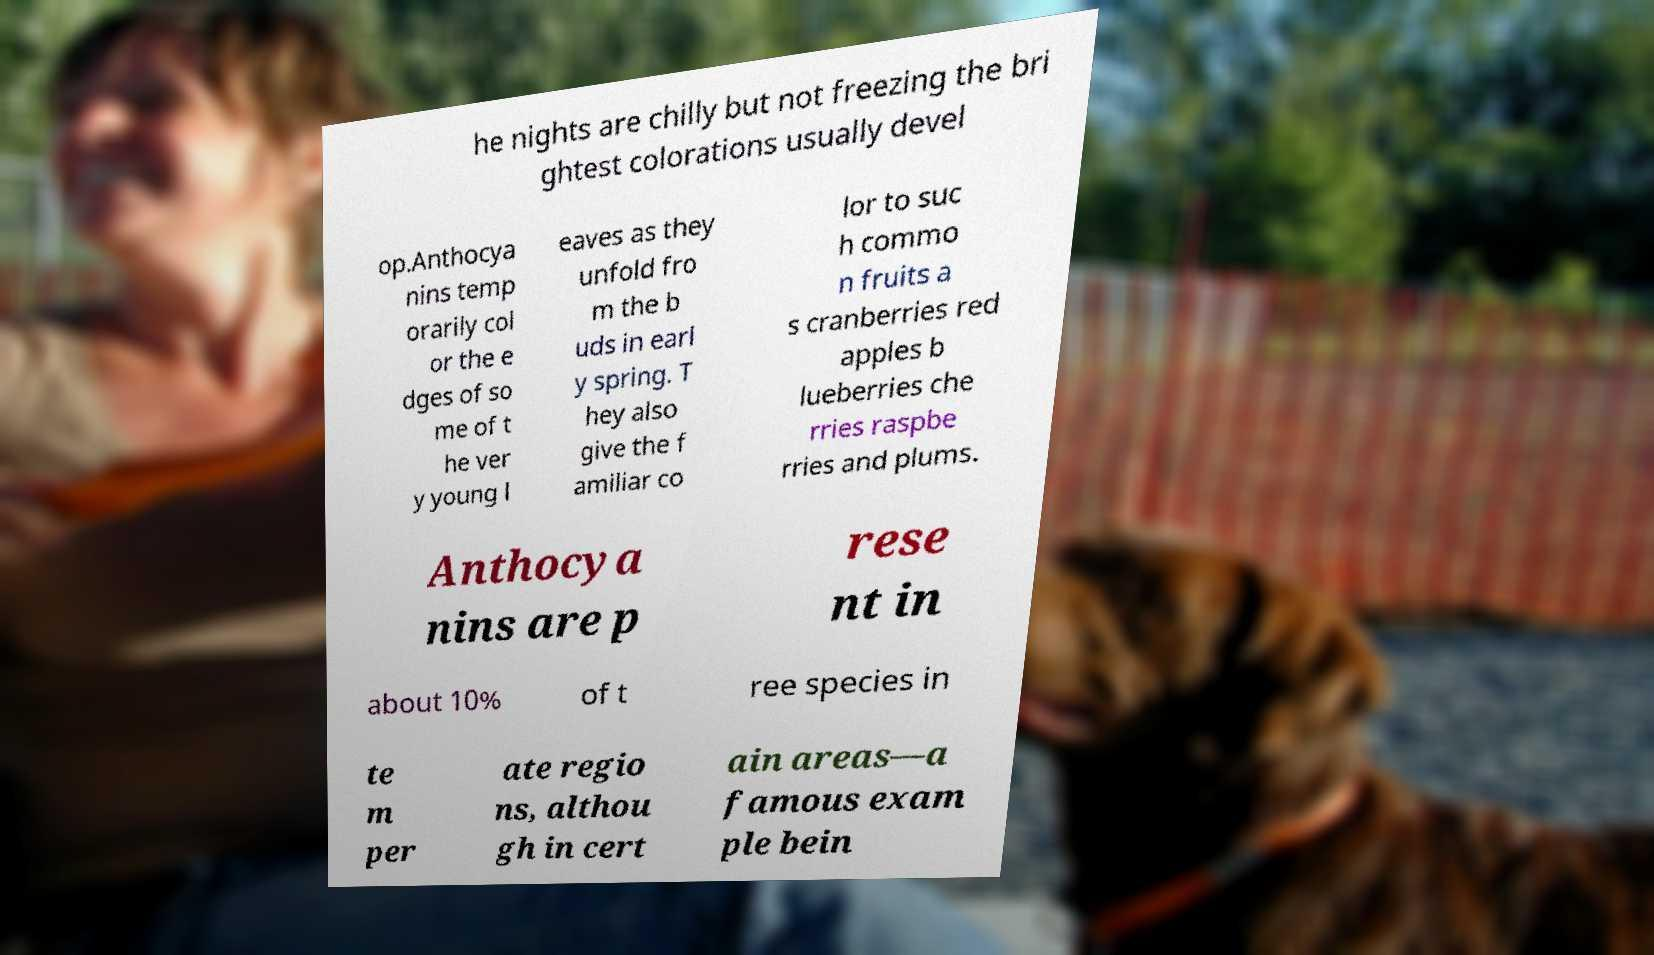Please read and relay the text visible in this image. What does it say? he nights are chilly but not freezing the bri ghtest colorations usually devel op.Anthocya nins temp orarily col or the e dges of so me of t he ver y young l eaves as they unfold fro m the b uds in earl y spring. T hey also give the f amiliar co lor to suc h commo n fruits a s cranberries red apples b lueberries che rries raspbe rries and plums. Anthocya nins are p rese nt in about 10% of t ree species in te m per ate regio ns, althou gh in cert ain areas—a famous exam ple bein 